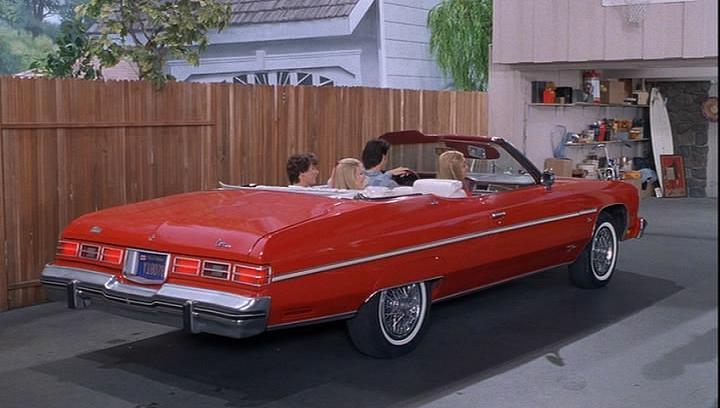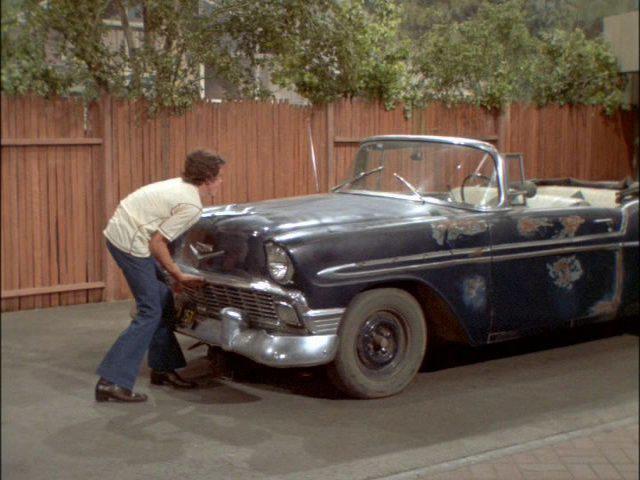The first image is the image on the left, the second image is the image on the right. Analyze the images presented: Is the assertion "A human is standing in front of a car in one photo." valid? Answer yes or no. Yes. The first image is the image on the left, the second image is the image on the right. Examine the images to the left and right. Is the description "An image shows a young male standing at the front of a beat-up looking convertible." accurate? Answer yes or no. Yes. 